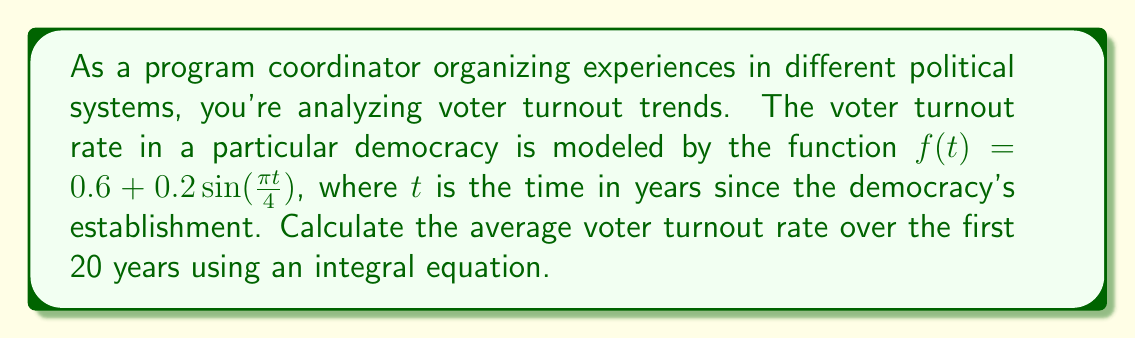Provide a solution to this math problem. To solve this problem, we'll follow these steps:

1) The average value of a function over an interval $[a,b]$ is given by the definite integral:

   $$\text{Average} = \frac{1}{b-a} \int_{a}^{b} f(t) dt$$

2) In this case, $a=0$, $b=20$, and $f(t) = 0.6 + 0.2\sin(\frac{\pi t}{4})$. Let's substitute these into the formula:

   $$\text{Average} = \frac{1}{20} \int_{0}^{20} (0.6 + 0.2\sin(\frac{\pi t}{4})) dt$$

3) Let's separate the integral:

   $$\text{Average} = \frac{1}{20} \left[\int_{0}^{20} 0.6 dt + \int_{0}^{20} 0.2\sin(\frac{\pi t}{4}) dt\right]$$

4) The first integral is straightforward:

   $$\int_{0}^{20} 0.6 dt = 0.6t \bigg|_{0}^{20} = 0.6(20) - 0.6(0) = 12$$

5) For the second integral, we use the substitution $u = \frac{\pi t}{4}$, so $du = \frac{\pi}{4} dt$, or $dt = \frac{4}{\pi} du$:

   $$\int_{0}^{20} 0.2\sin(\frac{\pi t}{4}) dt = \frac{0.8}{\pi} \int_{0}^{5\pi} \sin(u) du$$

6) Evaluate this integral:

   $$\frac{0.8}{\pi} [-\cos(u)]_{0}^{5\pi} = \frac{0.8}{\pi} [-\cos(5\pi) + \cos(0)] = \frac{0.8}{\pi} [-(-1) + 1] = \frac{1.6}{\pi}$$

7) Now, let's combine our results:

   $$\text{Average} = \frac{1}{20} (12 + \frac{1.6}{\pi}) = 0.6 + \frac{0.08}{\pi}$$

8) This can be simplified to:

   $$\text{Average} = 0.6 + \frac{0.08}{\pi} \approx 0.6255$$
Answer: $0.6 + \frac{0.08}{\pi}$ 